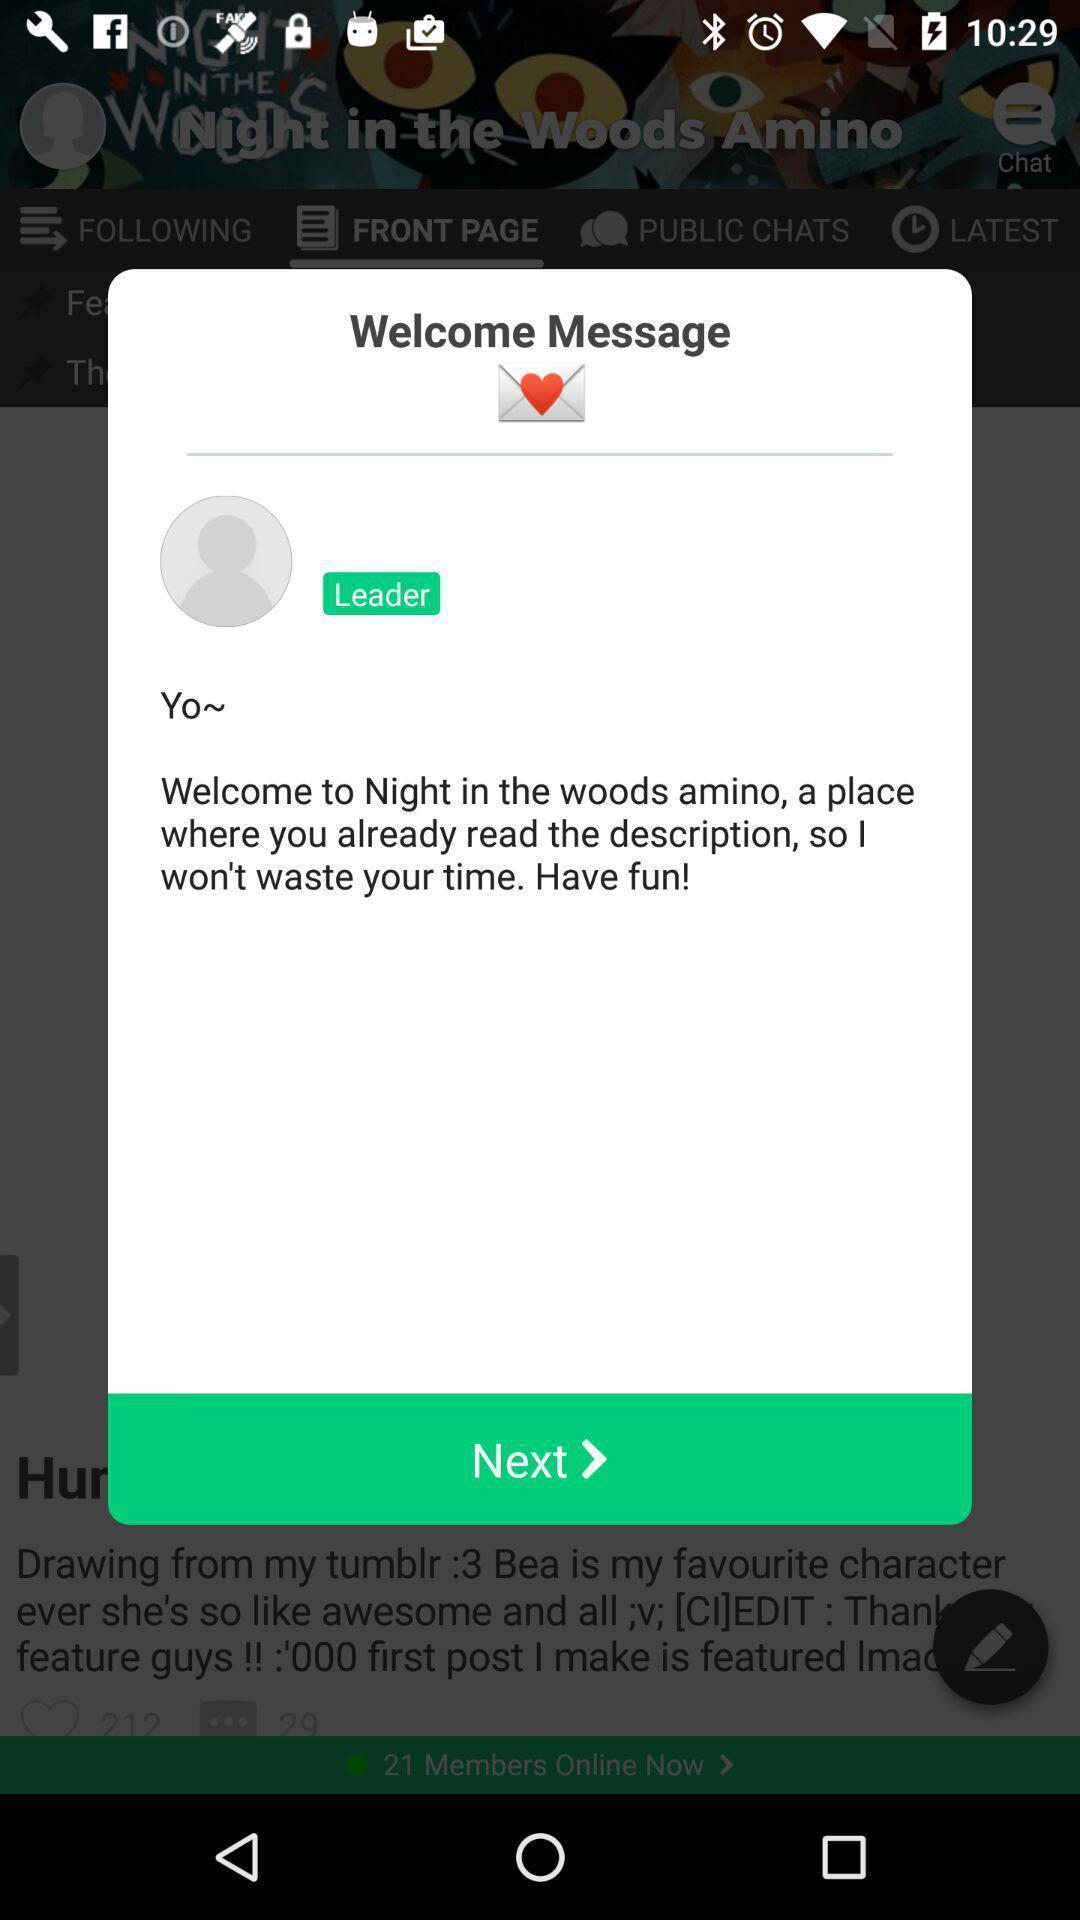Describe this image in words. Popup of welcome message in the animated stories app. 